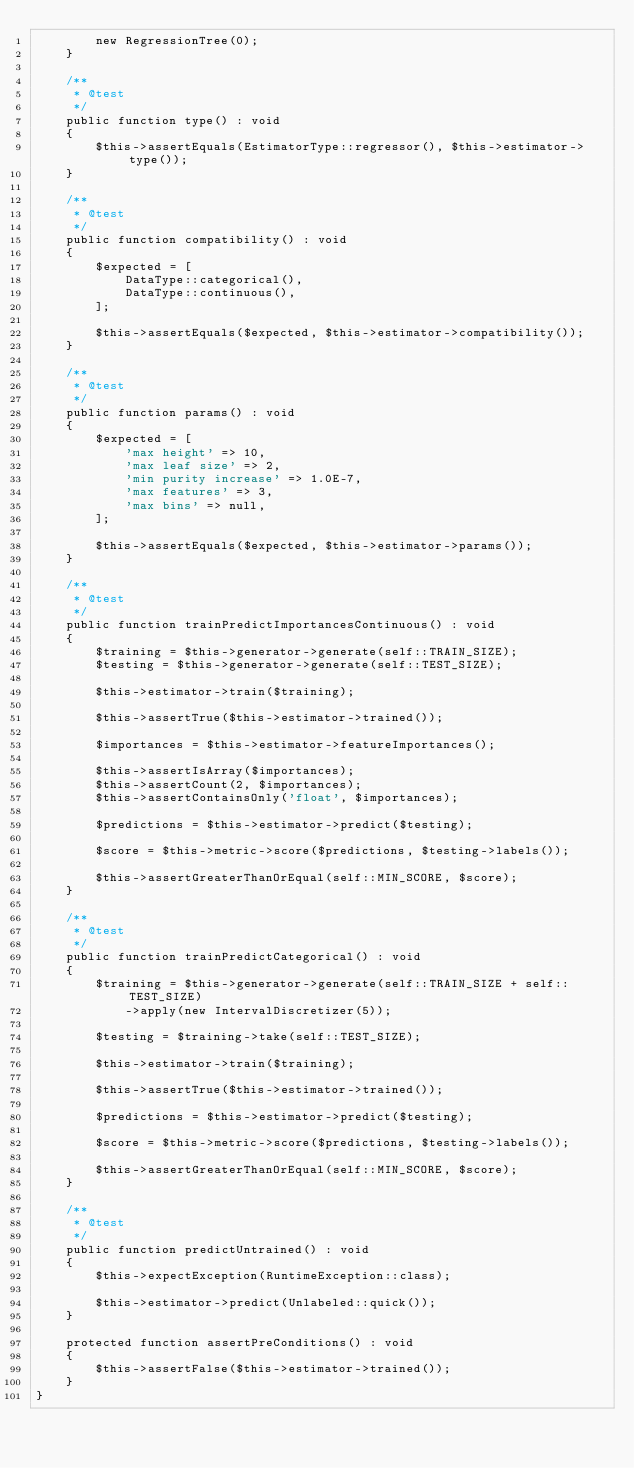<code> <loc_0><loc_0><loc_500><loc_500><_PHP_>        new RegressionTree(0);
    }

    /**
     * @test
     */
    public function type() : void
    {
        $this->assertEquals(EstimatorType::regressor(), $this->estimator->type());
    }

    /**
     * @test
     */
    public function compatibility() : void
    {
        $expected = [
            DataType::categorical(),
            DataType::continuous(),
        ];

        $this->assertEquals($expected, $this->estimator->compatibility());
    }

    /**
     * @test
     */
    public function params() : void
    {
        $expected = [
            'max height' => 10,
            'max leaf size' => 2,
            'min purity increase' => 1.0E-7,
            'max features' => 3,
            'max bins' => null,
        ];

        $this->assertEquals($expected, $this->estimator->params());
    }

    /**
     * @test
     */
    public function trainPredictImportancesContinuous() : void
    {
        $training = $this->generator->generate(self::TRAIN_SIZE);
        $testing = $this->generator->generate(self::TEST_SIZE);

        $this->estimator->train($training);

        $this->assertTrue($this->estimator->trained());

        $importances = $this->estimator->featureImportances();

        $this->assertIsArray($importances);
        $this->assertCount(2, $importances);
        $this->assertContainsOnly('float', $importances);

        $predictions = $this->estimator->predict($testing);

        $score = $this->metric->score($predictions, $testing->labels());

        $this->assertGreaterThanOrEqual(self::MIN_SCORE, $score);
    }

    /**
     * @test
     */
    public function trainPredictCategorical() : void
    {
        $training = $this->generator->generate(self::TRAIN_SIZE + self::TEST_SIZE)
            ->apply(new IntervalDiscretizer(5));

        $testing = $training->take(self::TEST_SIZE);

        $this->estimator->train($training);

        $this->assertTrue($this->estimator->trained());

        $predictions = $this->estimator->predict($testing);

        $score = $this->metric->score($predictions, $testing->labels());

        $this->assertGreaterThanOrEqual(self::MIN_SCORE, $score);
    }

    /**
     * @test
     */
    public function predictUntrained() : void
    {
        $this->expectException(RuntimeException::class);

        $this->estimator->predict(Unlabeled::quick());
    }

    protected function assertPreConditions() : void
    {
        $this->assertFalse($this->estimator->trained());
    }
}
</code> 